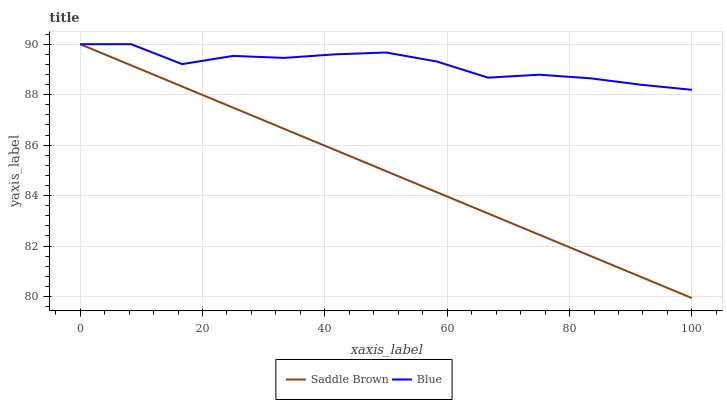Does Saddle Brown have the maximum area under the curve?
Answer yes or no. No. Is Saddle Brown the roughest?
Answer yes or no. No. 